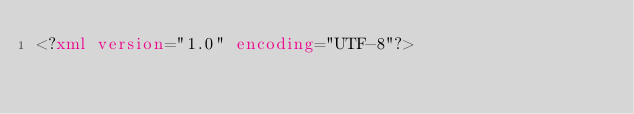Convert code to text. <code><loc_0><loc_0><loc_500><loc_500><_XML_><?xml version="1.0" encoding="UTF-8"?></code> 